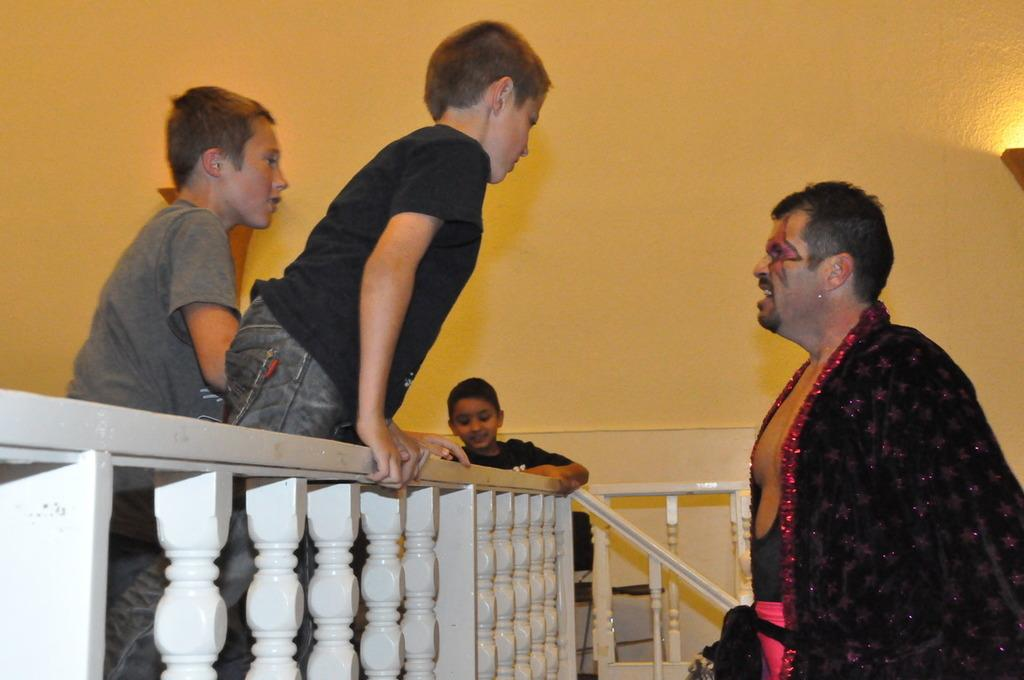What is the person on the right side of the image wearing? The person is wearing a black color shirt. What is the person standing in front of? The person is standing in front of a fencing. How many children are near the person? There are three children near the person. What color is the wall visible in the background of the image? The wall in the background is yellow color. What can be seen in the background of the image besides the wall? There is a light visible in the background of the image. What caption is written on the shirt of the person in the image? There is no caption visible on the shirt of the person in the image; it is simply described as a black color shirt. 